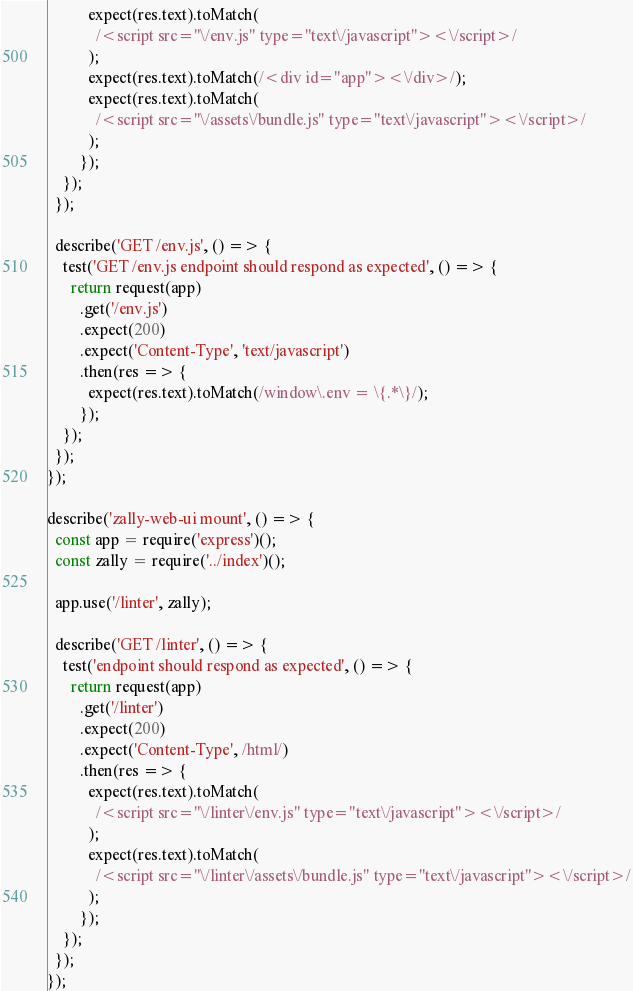<code> <loc_0><loc_0><loc_500><loc_500><_JavaScript_>          expect(res.text).toMatch(
            /<script src="\/env.js" type="text\/javascript"><\/script>/
          );
          expect(res.text).toMatch(/<div id="app"><\/div>/);
          expect(res.text).toMatch(
            /<script src="\/assets\/bundle.js" type="text\/javascript"><\/script>/
          );
        });
    });
  });

  describe('GET /env.js', () => {
    test('GET /env.js endpoint should respond as expected', () => {
      return request(app)
        .get('/env.js')
        .expect(200)
        .expect('Content-Type', 'text/javascript')
        .then(res => {
          expect(res.text).toMatch(/window\.env = \{.*\}/);
        });
    });
  });
});

describe('zally-web-ui mount', () => {
  const app = require('express')();
  const zally = require('../index')();

  app.use('/linter', zally);

  describe('GET /linter', () => {
    test('endpoint should respond as expected', () => {
      return request(app)
        .get('/linter')
        .expect(200)
        .expect('Content-Type', /html/)
        .then(res => {
          expect(res.text).toMatch(
            /<script src="\/linter\/env.js" type="text\/javascript"><\/script>/
          );
          expect(res.text).toMatch(
            /<script src="\/linter\/assets\/bundle.js" type="text\/javascript"><\/script>/
          );
        });
    });
  });
});
</code> 